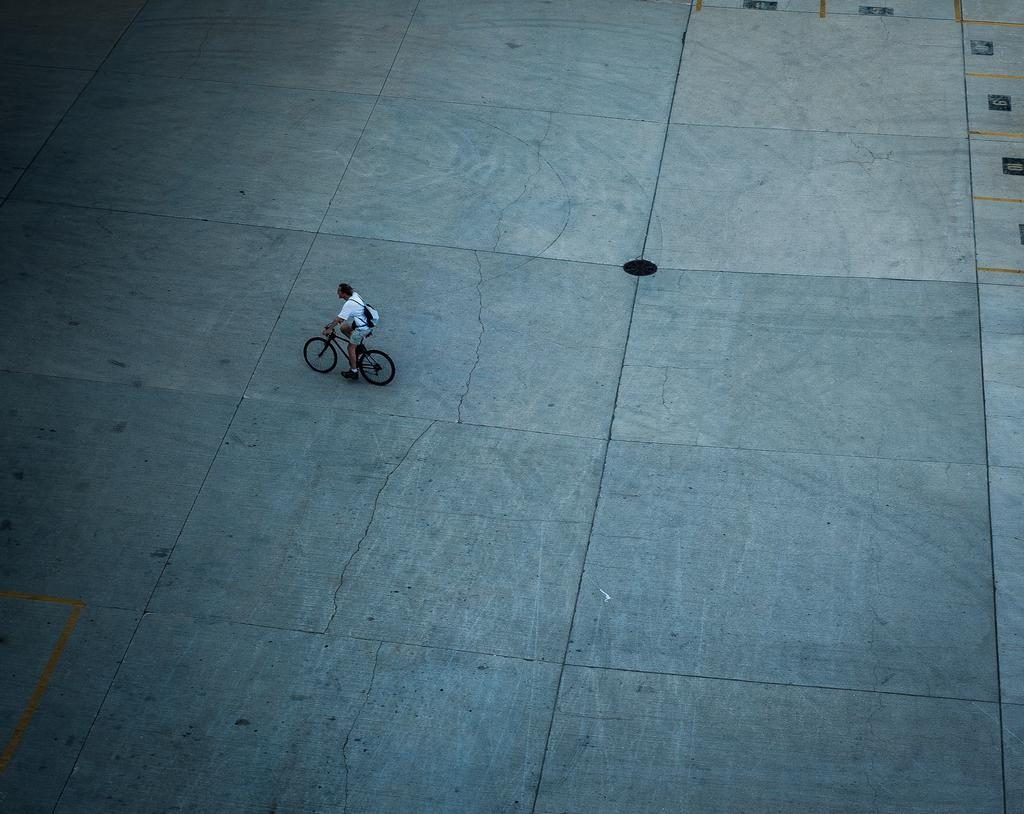Where was the image taken? The image is taken outdoors. What is at the bottom of the image? There is a floor at the bottom of the image. What is the man in the image doing? The man is riding a bicycle in the middle of the image. What type of drum is the man playing while riding the bicycle in the image? There is no drum present in the image; the man is simply riding a bicycle. 